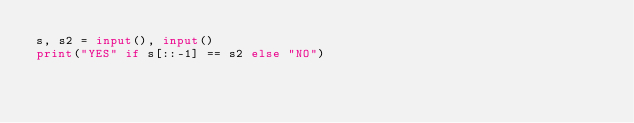Convert code to text. <code><loc_0><loc_0><loc_500><loc_500><_Python_>s, s2 = input(), input()
print("YES" if s[::-1] == s2 else "NO")</code> 